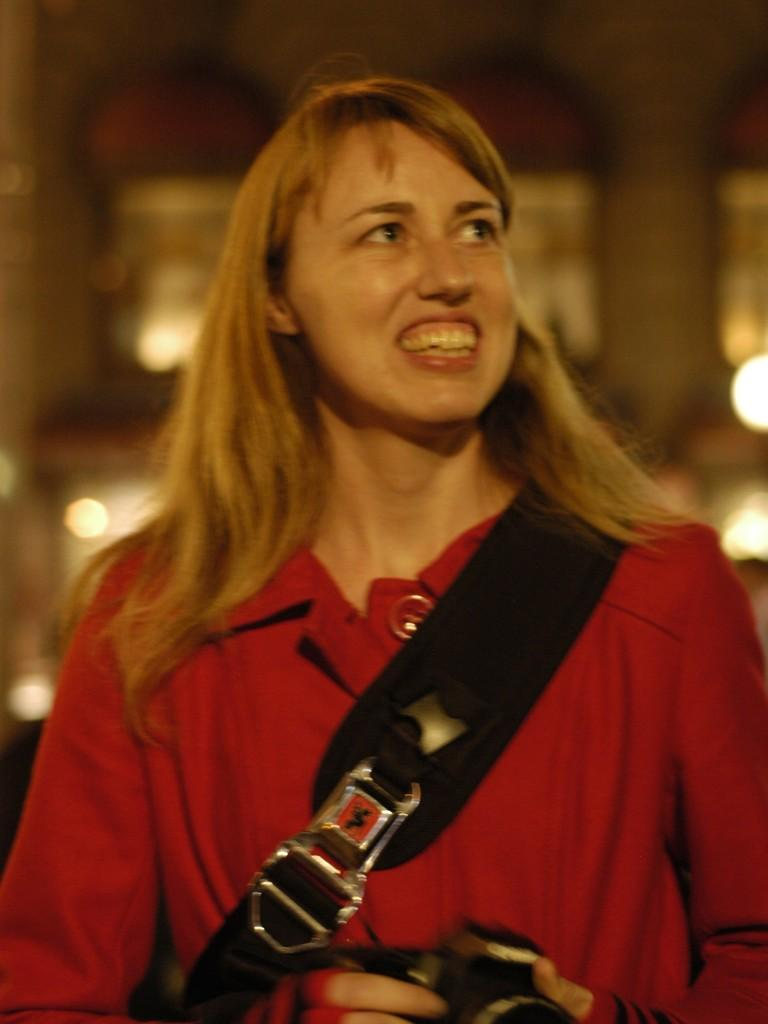What is the main subject of the image? There is a person in the image. What is the person doing in the image? The person is holding an object and standing. Can you describe the background of the image? The background of the image is blurred. What type of furniture can be seen in the image? There is no furniture present in the image. What is the taste of the letter the person is holding in the image? The person is not holding a letter in the image, and therefore, there is no taste to describe. 